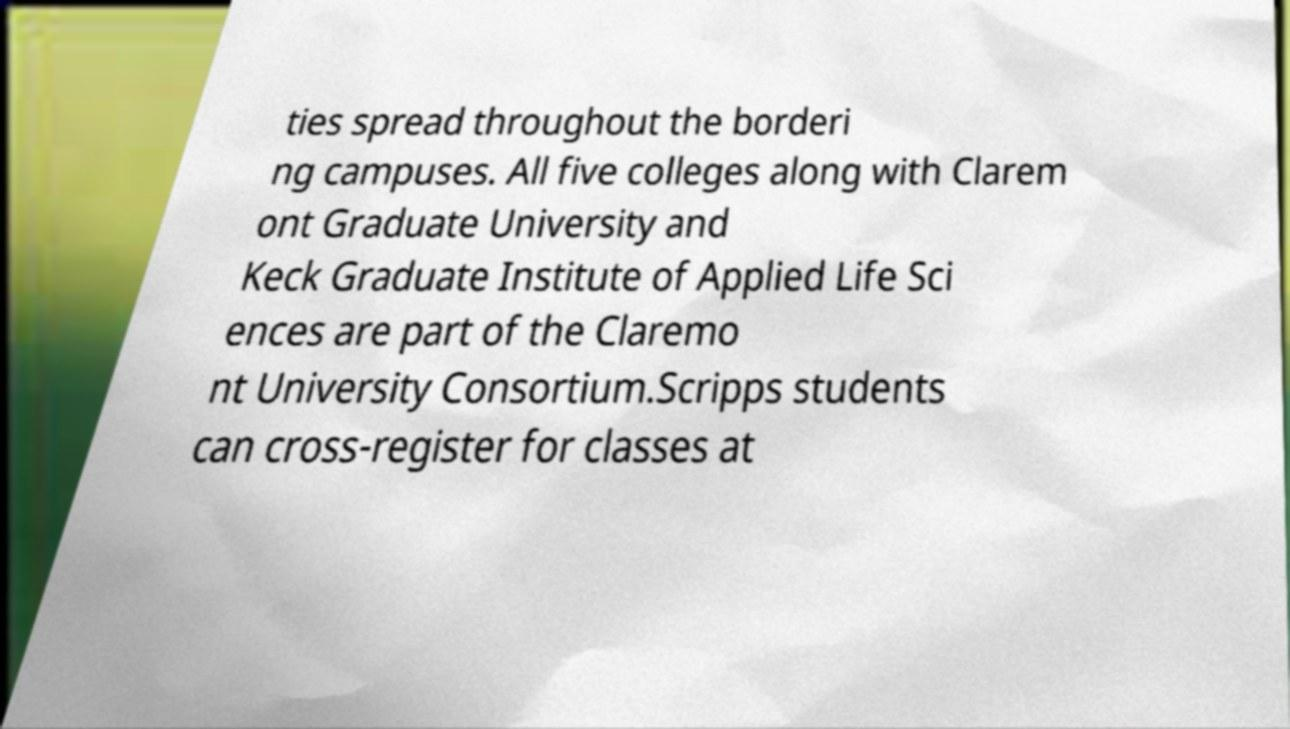For documentation purposes, I need the text within this image transcribed. Could you provide that? ties spread throughout the borderi ng campuses. All five colleges along with Clarem ont Graduate University and Keck Graduate Institute of Applied Life Sci ences are part of the Claremo nt University Consortium.Scripps students can cross-register for classes at 